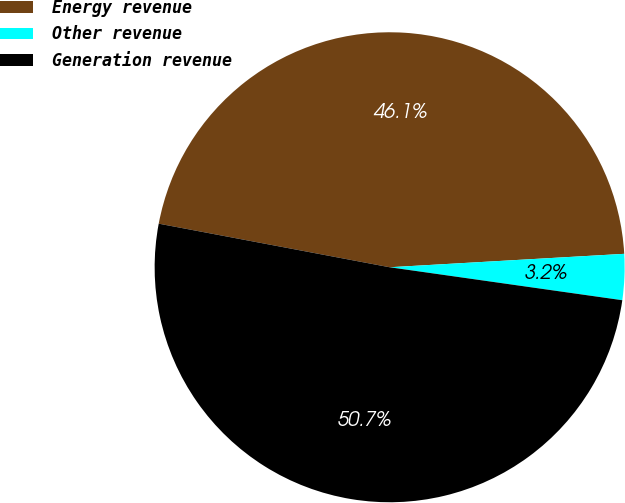<chart> <loc_0><loc_0><loc_500><loc_500><pie_chart><fcel>Energy revenue<fcel>Other revenue<fcel>Generation revenue<nl><fcel>46.12%<fcel>3.15%<fcel>50.73%<nl></chart> 